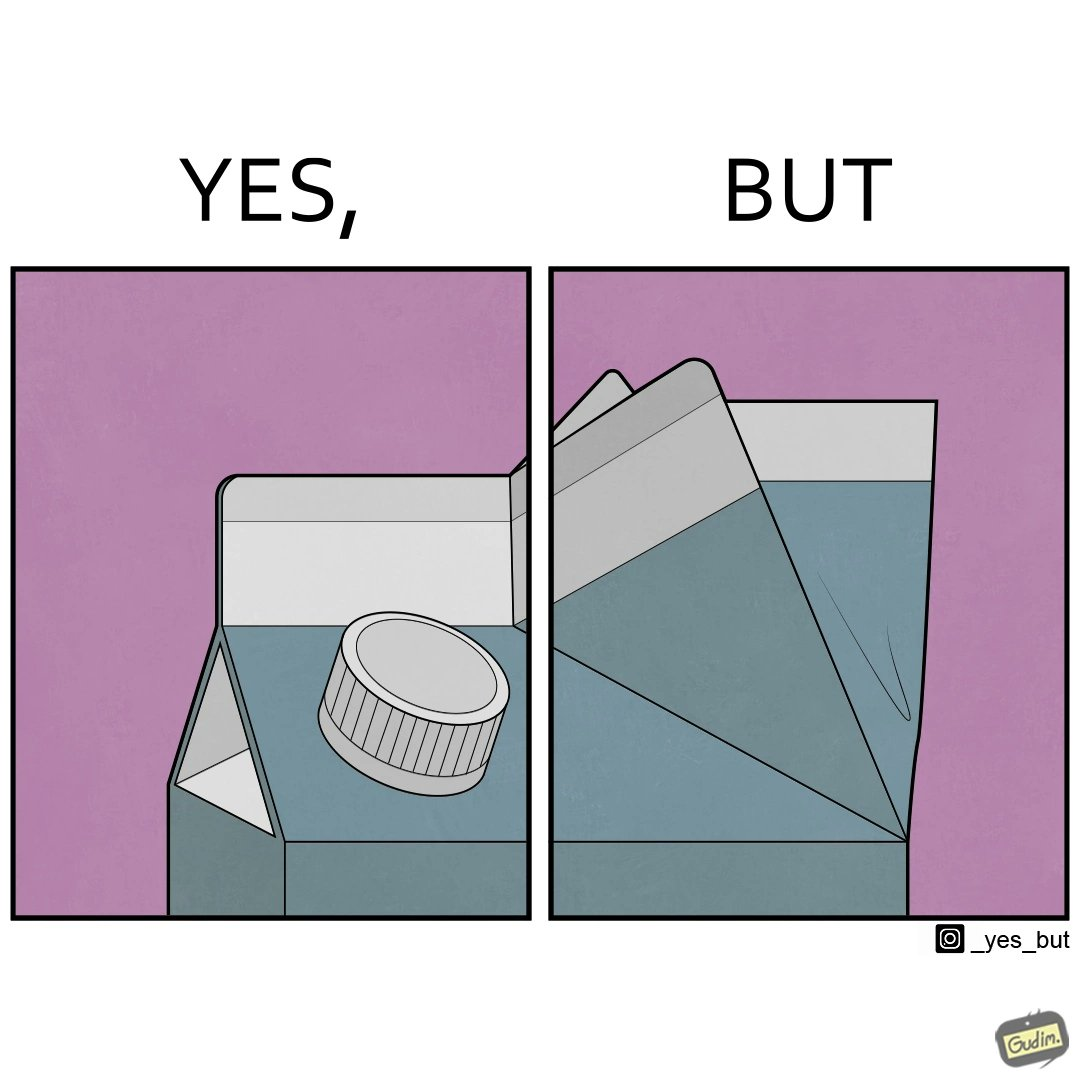Does this image contain satire or humor? Yes, this image is satirical. 